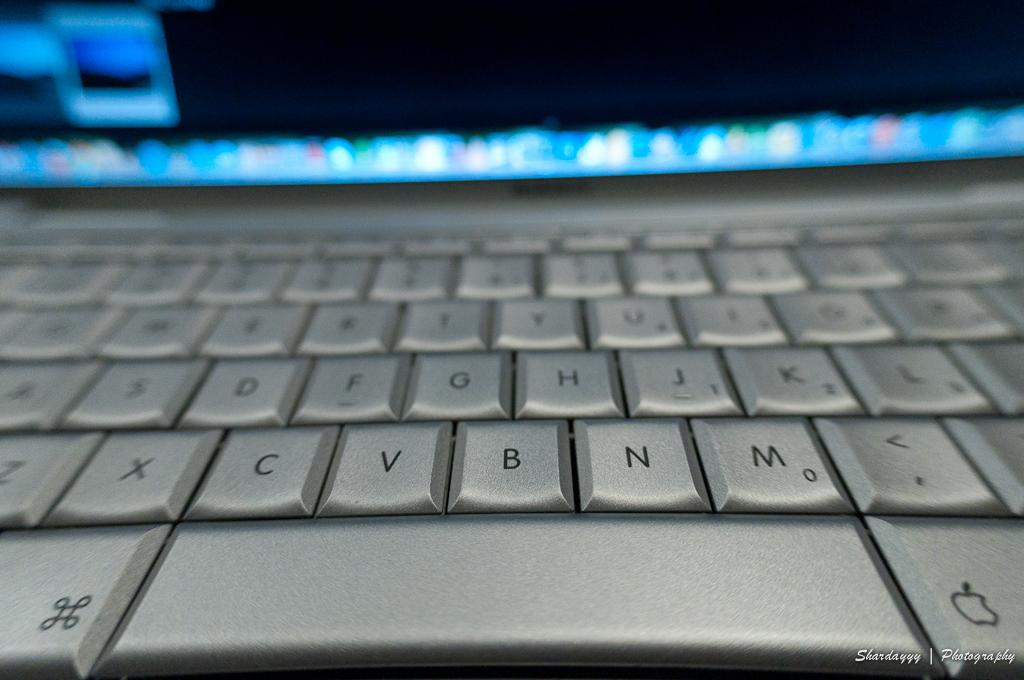<image>
Describe the image concisely. the letter N is on the silver keyboard 